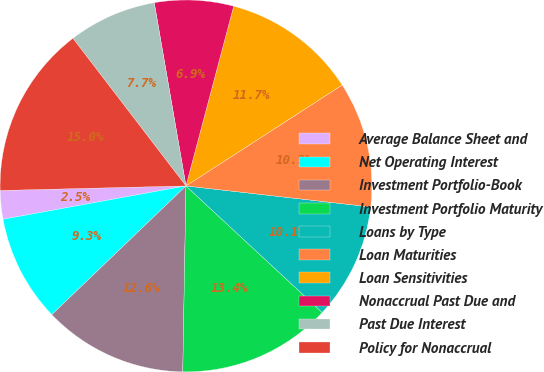Convert chart to OTSL. <chart><loc_0><loc_0><loc_500><loc_500><pie_chart><fcel>Average Balance Sheet and<fcel>Net Operating Interest<fcel>Investment Portfolio-Book<fcel>Investment Portfolio Maturity<fcel>Loans by Type<fcel>Loan Maturities<fcel>Loan Sensitivities<fcel>Nonaccrual Past Due and<fcel>Past Due Interest<fcel>Policy for Nonaccrual<nl><fcel>2.48%<fcel>9.3%<fcel>12.55%<fcel>13.36%<fcel>10.11%<fcel>10.93%<fcel>11.74%<fcel>6.86%<fcel>7.67%<fcel>14.99%<nl></chart> 